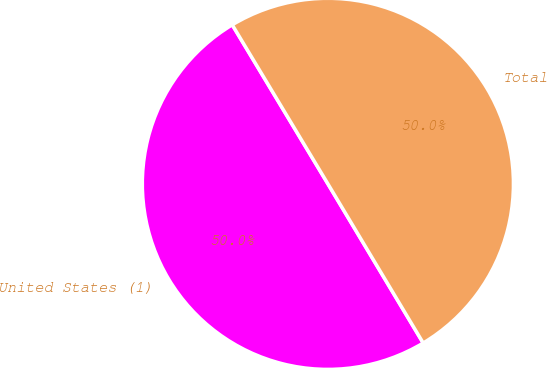<chart> <loc_0><loc_0><loc_500><loc_500><pie_chart><fcel>United States (1)<fcel>Total<nl><fcel>49.97%<fcel>50.03%<nl></chart> 